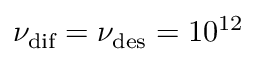Convert formula to latex. <formula><loc_0><loc_0><loc_500><loc_500>\nu _ { d i f } = \nu _ { d e s } = 1 0 ^ { 1 2 }</formula> 